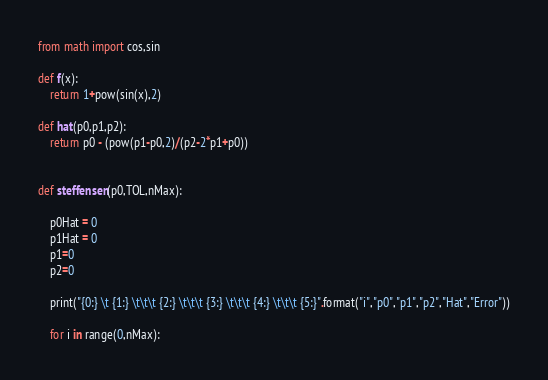Convert code to text. <code><loc_0><loc_0><loc_500><loc_500><_Python_>from math import cos,sin

def f(x):
    return 1+pow(sin(x),2)

def hat(p0,p1,p2):
    return p0 - (pow(p1-p0,2)/(p2-2*p1+p0))


def steffensen(p0,TOL,nMax):

    p0Hat = 0
    p1Hat = 0
    p1=0
    p2=0

    print("{0:} \t {1:} \t\t\t {2:} \t\t\t {3:} \t\t\t {4:} \t\t\t {5:}".format("i","p0","p1","p2","Hat","Error"))

    for i in range(0,nMax):</code> 